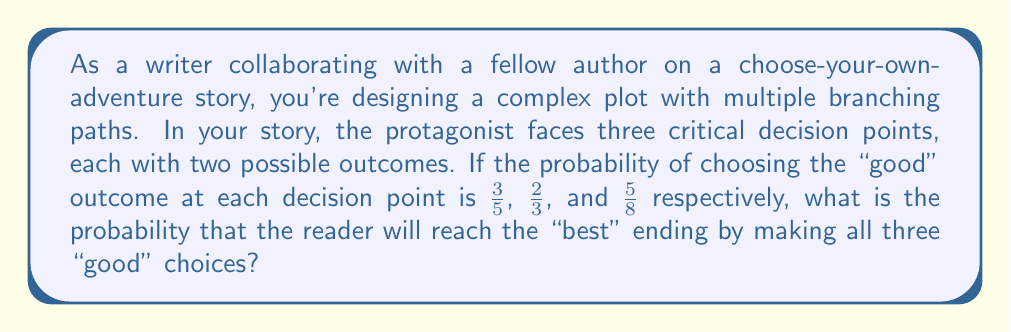Provide a solution to this math problem. To solve this problem, we need to understand that the probability of all three "good" choices occurring is the product of their individual probabilities. This is because we want the probability of independent events all occurring together.

Let's break it down step-by-step:

1. The probability of the first "good" choice is $\frac{3}{5}$.
2. The probability of the second "good" choice is $\frac{2}{3}$.
3. The probability of the third "good" choice is $\frac{5}{8}$.

To find the probability of all three occurring, we multiply these fractions:

$$P(\text{all good choices}) = \frac{3}{5} \times \frac{2}{3} \times \frac{5}{8}$$

Now, let's perform the multiplication:

$$\begin{aligned}
P(\text{all good choices}) &= \frac{3 \times 2 \times 5}{5 \times 3 \times 8} \\[6pt]
&= \frac{30}{120} \\[6pt]
&= \frac{1}{4}
\end{aligned}$$

We can simplify the fraction $\frac{30}{120}$ by dividing both the numerator and denominator by their greatest common divisor, which is 30:

$$\frac{30 \div 30}{120 \div 30} = \frac{1}{4}$$

Therefore, the probability of reaching the "best" ending by making all three "good" choices is $\frac{1}{4}$ or 0.25 or 25%.
Answer: $\frac{1}{4}$ or 0.25 or 25% 